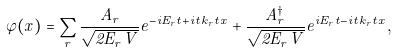Convert formula to latex. <formula><loc_0><loc_0><loc_500><loc_500>\varphi ( x ) = \sum _ { r } \frac { A _ { r } } { \sqrt { 2 E _ { r } V } } e ^ { - i E _ { r } t + i { \vec { t } { k } } _ { r } { \vec { t } { x } } } + \frac { A ^ { \dag } _ { r } } { \sqrt { 2 E _ { r } V } } e ^ { i E _ { r } t - i { \vec { t } { k } } _ { r } { \vec { t } { x } } } ,</formula> 